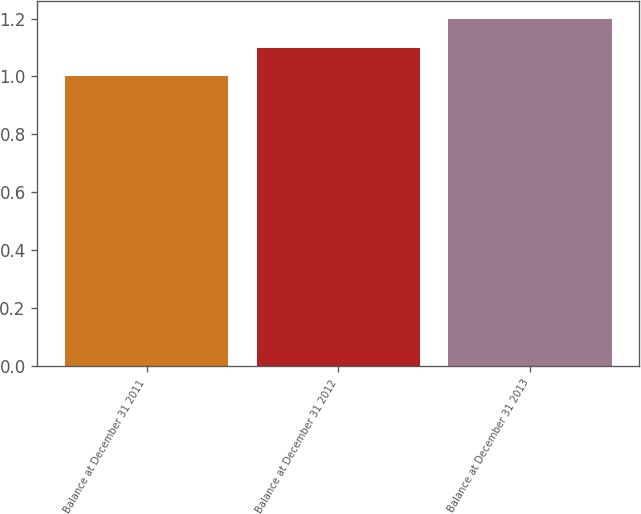<chart> <loc_0><loc_0><loc_500><loc_500><bar_chart><fcel>Balance at December 31 2011<fcel>Balance at December 31 2012<fcel>Balance at December 31 2013<nl><fcel>1<fcel>1.1<fcel>1.2<nl></chart> 